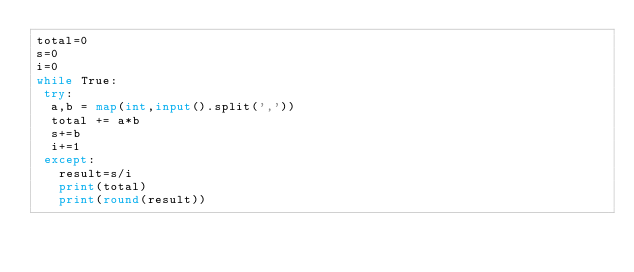<code> <loc_0><loc_0><loc_500><loc_500><_Python_>total=0
s=0
i=0
while True:
 try:
  a,b = map(int,input().split(','))
  total += a*b
  s+=b
  i+=1
 except:
   result=s/i
   print(total)
   print(round(result))</code> 